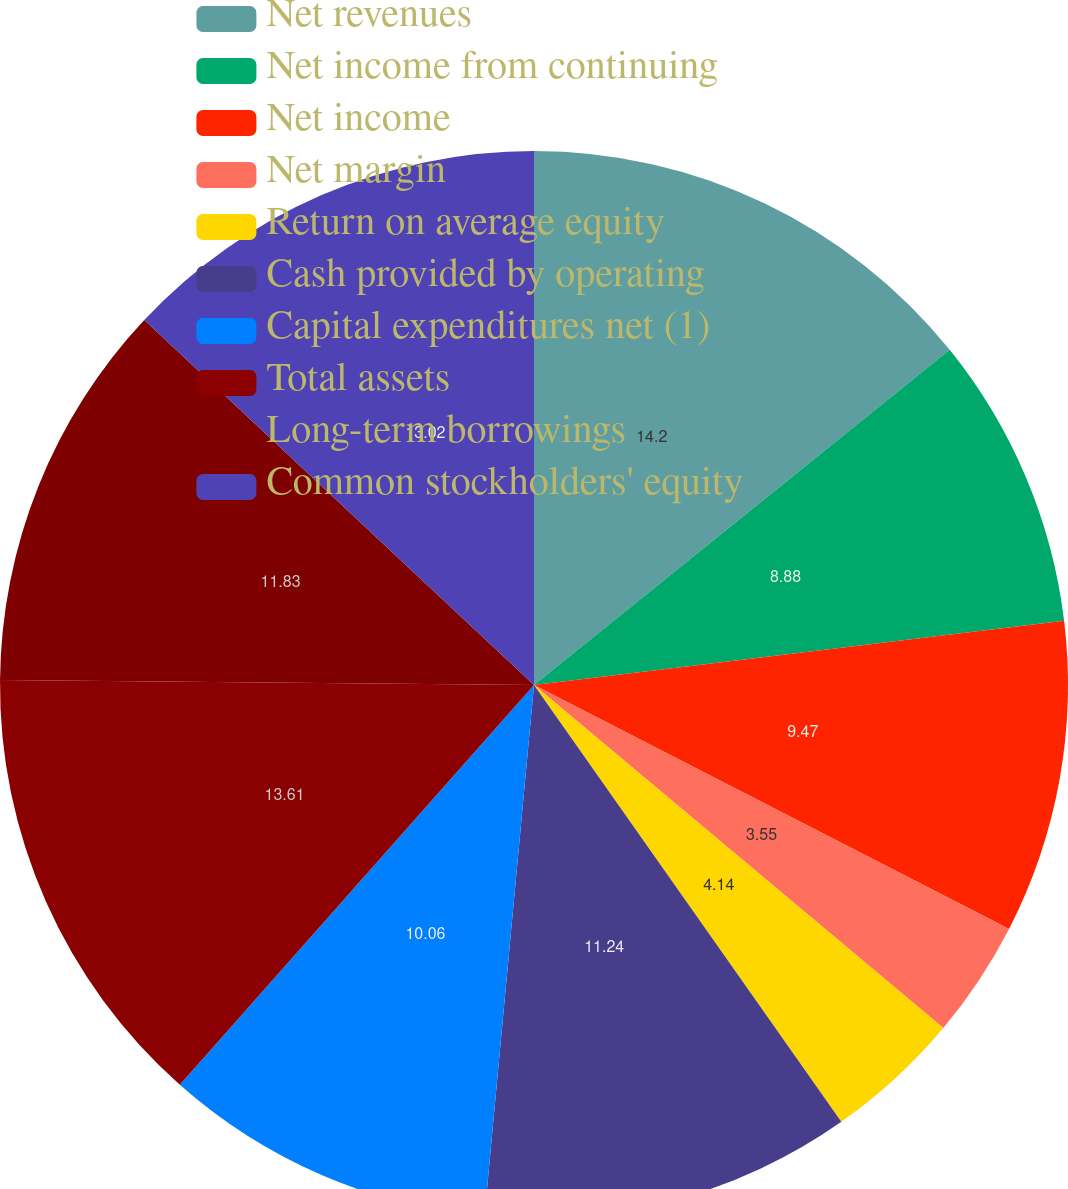Convert chart. <chart><loc_0><loc_0><loc_500><loc_500><pie_chart><fcel>Net revenues<fcel>Net income from continuing<fcel>Net income<fcel>Net margin<fcel>Return on average equity<fcel>Cash provided by operating<fcel>Capital expenditures net (1)<fcel>Total assets<fcel>Long-term borrowings<fcel>Common stockholders' equity<nl><fcel>14.2%<fcel>8.88%<fcel>9.47%<fcel>3.55%<fcel>4.14%<fcel>11.24%<fcel>10.06%<fcel>13.61%<fcel>11.83%<fcel>13.02%<nl></chart> 